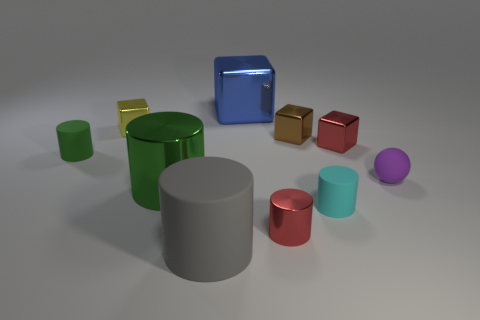Is there any other thing that has the same shape as the purple rubber object?
Your answer should be very brief. No. There is a small red object behind the green object on the right side of the small cube that is on the left side of the big gray cylinder; what shape is it?
Keep it short and to the point. Cube. Is there any other thing that is made of the same material as the red cube?
Your answer should be very brief. Yes. What shape is the red shiny object right of the cyan thing in front of the rubber sphere?
Make the answer very short. Cube. Do the large thing behind the small brown shiny thing and the large matte object have the same shape?
Offer a terse response. No. Are there more red shiny cylinders behind the green metallic cylinder than yellow metal objects that are to the right of the blue object?
Keep it short and to the point. No. There is a big thing that is on the right side of the gray rubber object; what number of large metallic objects are in front of it?
Give a very brief answer. 1. There is a small cylinder that is the same color as the large metallic cylinder; what is it made of?
Keep it short and to the point. Rubber. What number of other objects are the same color as the large rubber thing?
Make the answer very short. 0. There is a tiny metallic object in front of the matte object behind the purple object; what is its color?
Give a very brief answer. Red. 